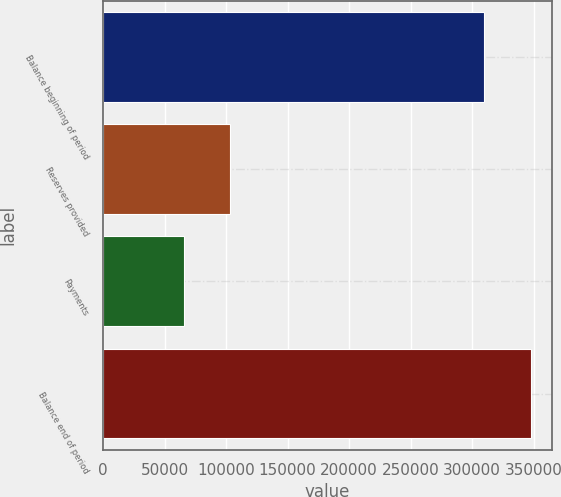<chart> <loc_0><loc_0><loc_500><loc_500><bar_chart><fcel>Balance beginning of period<fcel>Reserves provided<fcel>Payments<fcel>Balance end of period<nl><fcel>309900<fcel>103505<fcel>65774<fcel>347631<nl></chart> 